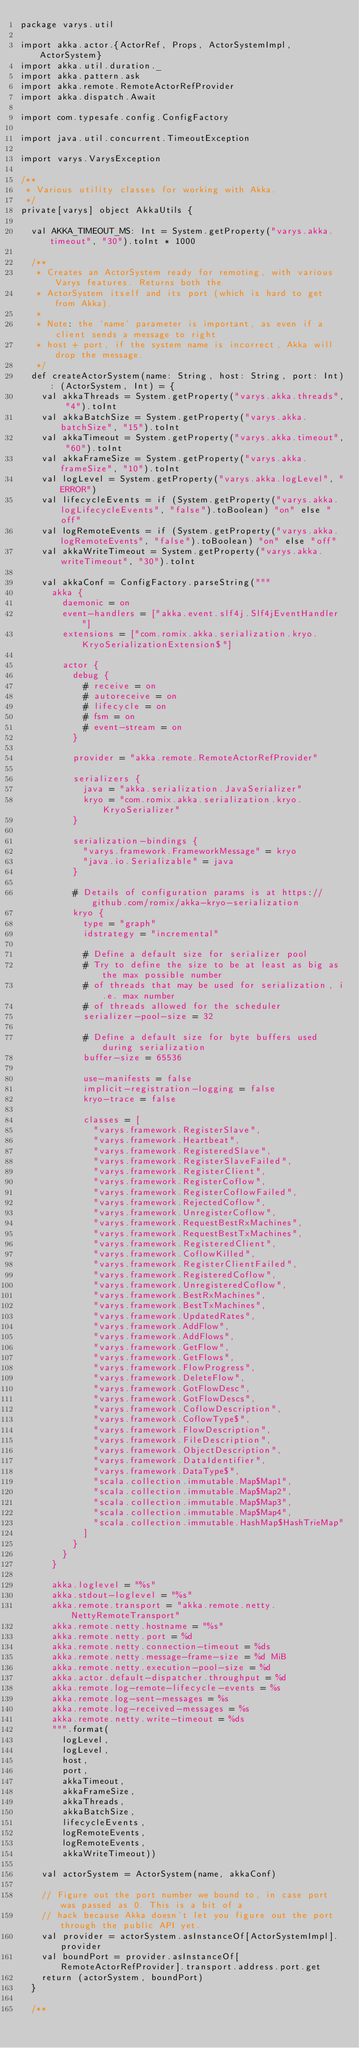Convert code to text. <code><loc_0><loc_0><loc_500><loc_500><_Scala_>package varys.util

import akka.actor.{ActorRef, Props, ActorSystemImpl, ActorSystem}
import akka.util.duration._
import akka.pattern.ask
import akka.remote.RemoteActorRefProvider
import akka.dispatch.Await

import com.typesafe.config.ConfigFactory

import java.util.concurrent.TimeoutException

import varys.VarysException

/**
 * Various utility classes for working with Akka.
 */
private[varys] object AkkaUtils {

  val AKKA_TIMEOUT_MS: Int = System.getProperty("varys.akka.timeout", "30").toInt * 1000

  /**
   * Creates an ActorSystem ready for remoting, with various Varys features. Returns both the
   * ActorSystem itself and its port (which is hard to get from Akka).
   *
   * Note: the `name` parameter is important, as even if a client sends a message to right
   * host + port, if the system name is incorrect, Akka will drop the message.
   */
  def createActorSystem(name: String, host: String, port: Int): (ActorSystem, Int) = {
    val akkaThreads = System.getProperty("varys.akka.threads", "4").toInt
    val akkaBatchSize = System.getProperty("varys.akka.batchSize", "15").toInt
    val akkaTimeout = System.getProperty("varys.akka.timeout", "60").toInt
    val akkaFrameSize = System.getProperty("varys.akka.frameSize", "10").toInt
    val logLevel = System.getProperty("varys.akka.logLevel", "ERROR")
    val lifecycleEvents = if (System.getProperty("varys.akka.logLifecycleEvents", "false").toBoolean) "on" else "off"
    val logRemoteEvents = if (System.getProperty("varys.akka.logRemoteEvents", "false").toBoolean) "on" else "off"
    val akkaWriteTimeout = System.getProperty("varys.akka.writeTimeout", "30").toInt

    val akkaConf = ConfigFactory.parseString("""
      akka {
        daemonic = on
        event-handlers = ["akka.event.slf4j.Slf4jEventHandler"]
        extensions = ["com.romix.akka.serialization.kryo.KryoSerializationExtension$"]

        actor {
          debug {
            # receive = on
            # autoreceive = on
            # lifecycle = on
            # fsm = on
            # event-stream = on
          }
         
          provider = "akka.remote.RemoteActorRefProvider"

          serializers {  
            java = "akka.serialization.JavaSerializer"
            kryo = "com.romix.akka.serialization.kryo.KryoSerializer"
          }

          serialization-bindings {
            "varys.framework.FrameworkMessage" = kryo
            "java.io.Serializable" = java
          }

          # Details of configuration params is at https://github.com/romix/akka-kryo-serialization
          kryo {
            type = "graph"  
            idstrategy = "incremental"  

            # Define a default size for serializer pool
            # Try to define the size to be at least as big as the max possible number
            # of threads that may be used for serialization, i.e. max number
            # of threads allowed for the scheduler
            serializer-pool-size = 32

            # Define a default size for byte buffers used during serialization
            buffer-size = 65536  

            use-manifests = false
            implicit-registration-logging = false 
            kryo-trace = false

            classes = [
              "varys.framework.RegisterSlave",  
              "varys.framework.Heartbeat",
              "varys.framework.RegisteredSlave",
              "varys.framework.RegisterSlaveFailed",
              "varys.framework.RegisterClient",
              "varys.framework.RegisterCoflow",
              "varys.framework.RegisterCoflowFailed",
              "varys.framework.RejectedCoflow",
              "varys.framework.UnregisterCoflow",
              "varys.framework.RequestBestRxMachines",
              "varys.framework.RequestBestTxMachines",
              "varys.framework.RegisteredClient",
              "varys.framework.CoflowKilled",
              "varys.framework.RegisterClientFailed",
              "varys.framework.RegisteredCoflow",
              "varys.framework.UnregisteredCoflow",
              "varys.framework.BestRxMachines",
              "varys.framework.BestTxMachines",
              "varys.framework.UpdatedRates",
              "varys.framework.AddFlow",
              "varys.framework.AddFlows",
              "varys.framework.GetFlow",
              "varys.framework.GetFlows",
              "varys.framework.FlowProgress",
              "varys.framework.DeleteFlow",
              "varys.framework.GotFlowDesc",
              "varys.framework.GotFlowDescs",
              "varys.framework.CoflowDescription",
              "varys.framework.CoflowType$",
              "varys.framework.FlowDescription",
              "varys.framework.FileDescription",
              "varys.framework.ObjectDescription",
              "varys.framework.DataIdentifier",
              "varys.framework.DataType$",
              "scala.collection.immutable.Map$Map1",
              "scala.collection.immutable.Map$Map2",
              "scala.collection.immutable.Map$Map3",
              "scala.collection.immutable.Map$Map4",
              "scala.collection.immutable.HashMap$HashTrieMap"
            ]  
          }
        }
      }

      akka.loglevel = "%s"
      akka.stdout-loglevel = "%s"
      akka.remote.transport = "akka.remote.netty.NettyRemoteTransport"
      akka.remote.netty.hostname = "%s"
      akka.remote.netty.port = %d
      akka.remote.netty.connection-timeout = %ds
      akka.remote.netty.message-frame-size = %d MiB
      akka.remote.netty.execution-pool-size = %d
      akka.actor.default-dispatcher.throughput = %d
      akka.remote.log-remote-lifecycle-events = %s
      akka.remote.log-sent-messages = %s
      akka.remote.log-received-messages = %s
      akka.remote.netty.write-timeout = %ds
      """.format(
        logLevel, 
        logLevel, 
        host, 
        port, 
        akkaTimeout, 
        akkaFrameSize, 
        akkaThreads, 
        akkaBatchSize,
        lifecycleEvents, 
        logRemoteEvents, 
        logRemoteEvents, 
        akkaWriteTimeout))

    val actorSystem = ActorSystem(name, akkaConf)

    // Figure out the port number we bound to, in case port was passed as 0. This is a bit of a
    // hack because Akka doesn't let you figure out the port through the public API yet.
    val provider = actorSystem.asInstanceOf[ActorSystemImpl].provider
    val boundPort = provider.asInstanceOf[RemoteActorRefProvider].transport.address.port.get
    return (actorSystem, boundPort)
  }

  /** </code> 